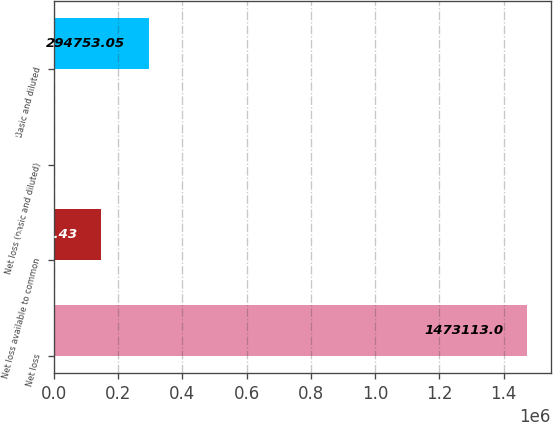Convert chart to OTSL. <chart><loc_0><loc_0><loc_500><loc_500><bar_chart><fcel>Net loss<fcel>Net loss available to common<fcel>Net loss (basic and diluted)<fcel>Basic and diluted<nl><fcel>1.47311e+06<fcel>147379<fcel>5.81<fcel>294753<nl></chart> 